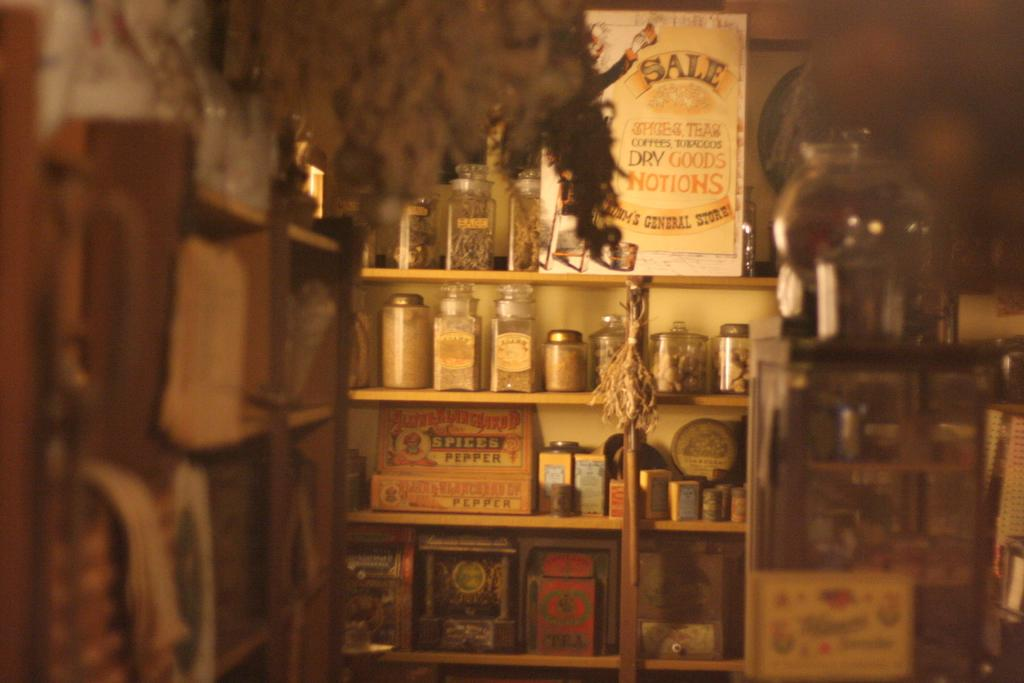What type of objects can be seen on shelves in the image? There are jars on shelves in the image. Can you describe any other objects or items visible in the image? Unfortunately, the provided facts do not specify any other items in the image. How are the parents, dad and mom, involved in the feast depicted in the image? There is no mention of a feast or parents in the image, so it is not possible to answer this question. 